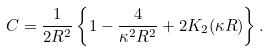Convert formula to latex. <formula><loc_0><loc_0><loc_500><loc_500>C = \frac { 1 } { 2 R ^ { 2 } } \left \{ 1 - \frac { 4 } { \kappa ^ { 2 } R ^ { 2 } } + 2 K _ { 2 } ( \kappa R ) \right \} .</formula> 